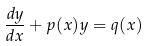Convert formula to latex. <formula><loc_0><loc_0><loc_500><loc_500>\frac { d y } { d x } + p ( x ) y = q ( x )</formula> 